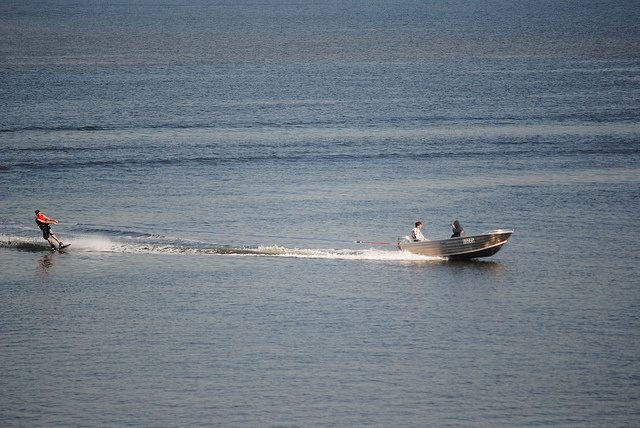Describe the objects in this image and their specific colors. I can see boat in blue, black, gray, darkgray, and tan tones, people in blue, black, gray, tan, and maroon tones, people in blue, lightgray, darkgray, gray, and salmon tones, people in blue, black, and gray tones, and skis in blue, black, and gray tones in this image. 